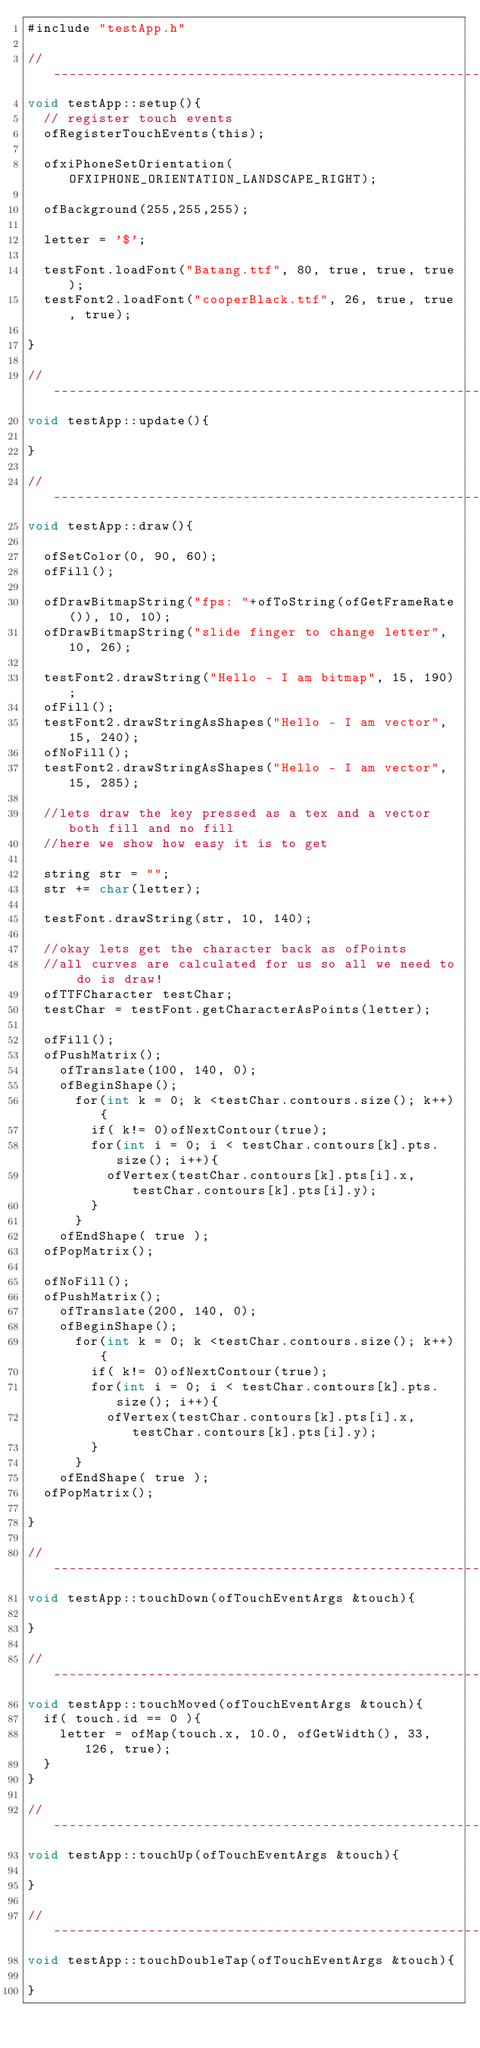Convert code to text. <code><loc_0><loc_0><loc_500><loc_500><_ObjectiveC_>#include "testApp.h"

//--------------------------------------------------------------
void testApp::setup(){	
	// register touch events
	ofRegisterTouchEvents(this);

	ofxiPhoneSetOrientation(OFXIPHONE_ORIENTATION_LANDSCAPE_RIGHT);
	
	ofBackground(255,255,255);	

	letter = '$';

	testFont.loadFont("Batang.ttf", 80, true, true, true);
	testFont2.loadFont("cooperBlack.ttf", 26, true, true, true);

}

//--------------------------------------------------------------
void testApp::update(){
	
}

//--------------------------------------------------------------
void testApp::draw(){

	ofSetColor(0, 90, 60);
	ofFill();

	ofDrawBitmapString("fps: "+ofToString(ofGetFrameRate()), 10, 10);
	ofDrawBitmapString("slide finger to change letter", 10, 26);

	testFont2.drawString("Hello - I am bitmap", 15, 190);
	ofFill();
	testFont2.drawStringAsShapes("Hello - I am vector", 15, 240);
	ofNoFill();
	testFont2.drawStringAsShapes("Hello - I am vector", 15, 285);

	//lets draw the key pressed as a tex and a vector both fill and no fill
	//here we show how easy it is to get

	string str = "";
	str += char(letter);

	testFont.drawString(str, 10, 140);

	//okay lets get the character back as ofPoints
	//all curves are calculated for us so all we need to do is draw!
	ofTTFCharacter testChar;
	testChar = testFont.getCharacterAsPoints(letter);

	ofFill();
	ofPushMatrix();
		ofTranslate(100, 140, 0);
		ofBeginShape();
			for(int k = 0; k <testChar.contours.size(); k++){
				if( k!= 0)ofNextContour(true);
				for(int i = 0; i < testChar.contours[k].pts.size(); i++){
					ofVertex(testChar.contours[k].pts[i].x, testChar.contours[k].pts[i].y);
				}
			}
		ofEndShape( true );
	ofPopMatrix();

	ofNoFill();
	ofPushMatrix();
		ofTranslate(200, 140, 0);
		ofBeginShape();
			for(int k = 0; k <testChar.contours.size(); k++){
				if( k!= 0)ofNextContour(true);
				for(int i = 0; i < testChar.contours[k].pts.size(); i++){
					ofVertex(testChar.contours[k].pts[i].x, testChar.contours[k].pts[i].y);
				}
			}
		ofEndShape( true );
	ofPopMatrix();

}

//--------------------------------------------------------------
void testApp::touchDown(ofTouchEventArgs &touch){

}

//--------------------------------------------------------------
void testApp::touchMoved(ofTouchEventArgs &touch){
	if( touch.id == 0 ){
		letter = ofMap(touch.x, 10.0, ofGetWidth(), 33, 126, true);
	}
}

//--------------------------------------------------------------
void testApp::touchUp(ofTouchEventArgs &touch){

}

//--------------------------------------------------------------
void testApp::touchDoubleTap(ofTouchEventArgs &touch){

}
</code> 